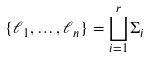<formula> <loc_0><loc_0><loc_500><loc_500>\{ \ell _ { 1 } , \dots , \ell _ { n } \} = \bigsqcup _ { i = 1 } ^ { r } \Sigma _ { i }</formula> 